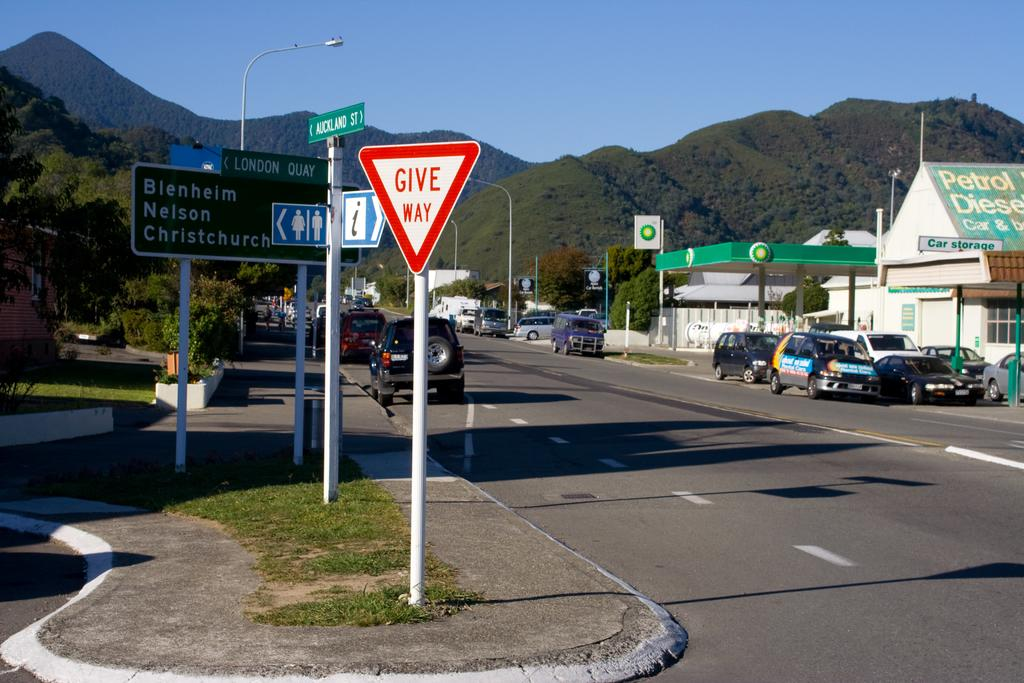<image>
Offer a succinct explanation of the picture presented. A red and white sign has the instruction to give way on it. 